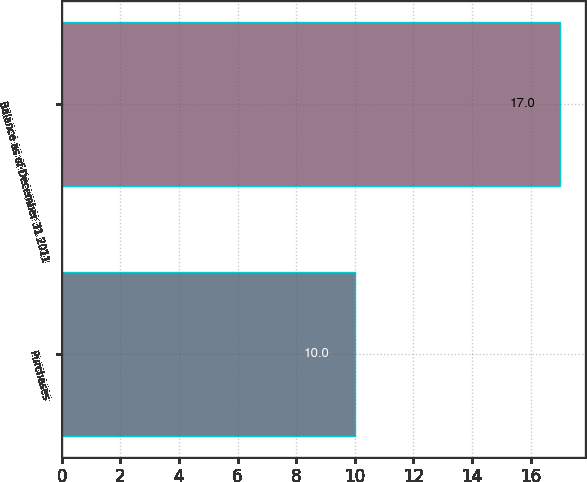<chart> <loc_0><loc_0><loc_500><loc_500><bar_chart><fcel>Purchases<fcel>Balance as of December 31 2011<nl><fcel>10<fcel>17<nl></chart> 